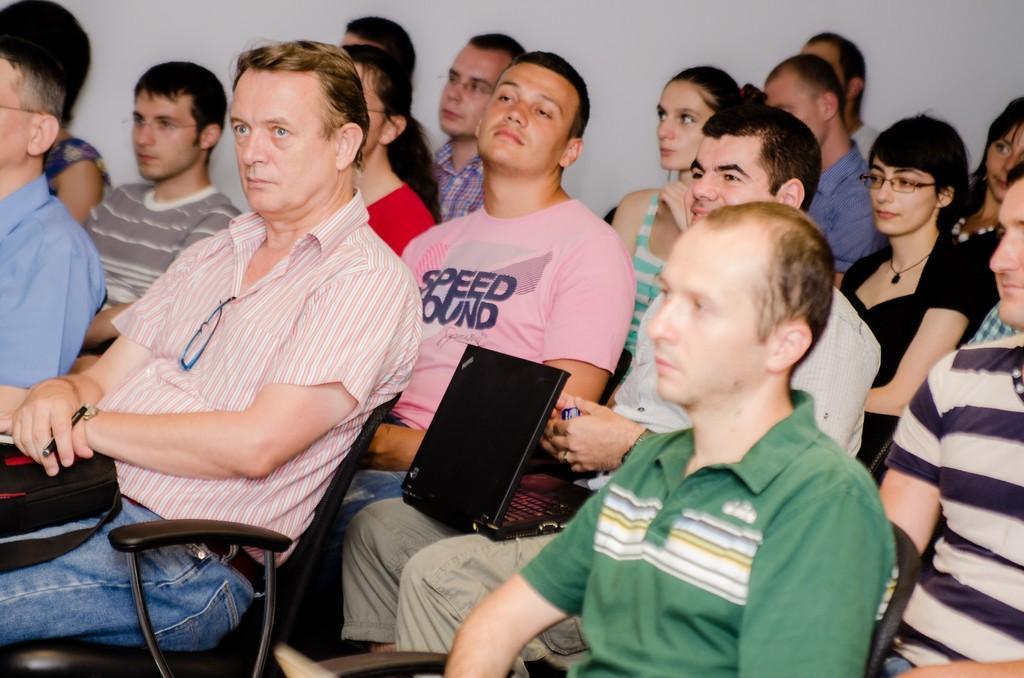Please provide a concise description of this image. In the picture I can see a group of people are sitting on chairs. I can also see a laptop, a white color wall and some other objects. 